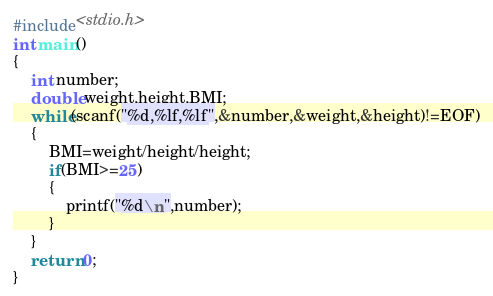Convert code to text. <code><loc_0><loc_0><loc_500><loc_500><_C_>#include<stdio.h>
int main()
{
	int number;
	double weight,height,BMI;
	while(scanf("%d,%lf,%lf",&number,&weight,&height)!=EOF)
	{
		BMI=weight/height/height;
		if(BMI>=25)
		{
			printf("%d\n",number);
		}
	}
	return 0;
}</code> 